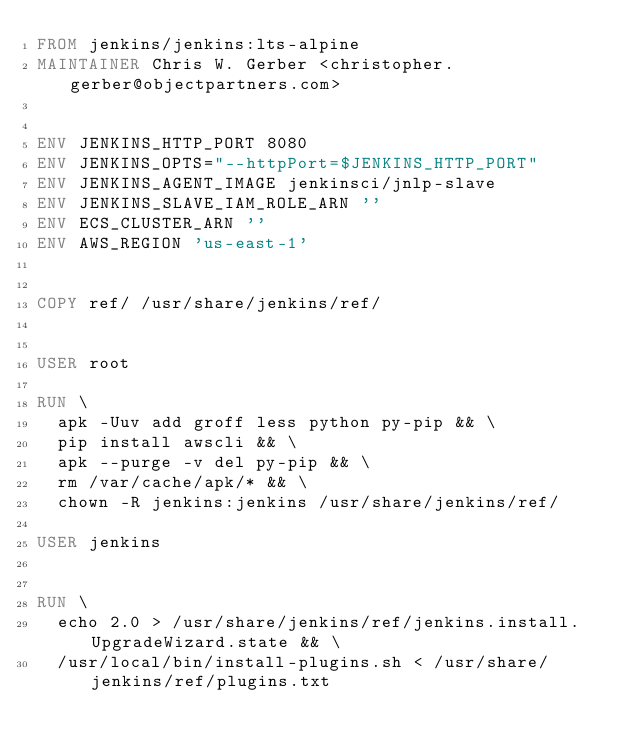<code> <loc_0><loc_0><loc_500><loc_500><_Dockerfile_>FROM jenkins/jenkins:lts-alpine
MAINTAINER Chris W. Gerber <christopher.gerber@objectpartners.com>


ENV JENKINS_HTTP_PORT 8080
ENV JENKINS_OPTS="--httpPort=$JENKINS_HTTP_PORT"
ENV JENKINS_AGENT_IMAGE jenkinsci/jnlp-slave
ENV JENKINS_SLAVE_IAM_ROLE_ARN ''
ENV ECS_CLUSTER_ARN ''
ENV AWS_REGION 'us-east-1'


COPY ref/ /usr/share/jenkins/ref/


USER root

RUN \
  apk -Uuv add groff less python py-pip && \
  pip install awscli && \
  apk --purge -v del py-pip && \
  rm /var/cache/apk/* && \
  chown -R jenkins:jenkins /usr/share/jenkins/ref/

USER jenkins


RUN \
  echo 2.0 > /usr/share/jenkins/ref/jenkins.install.UpgradeWizard.state && \
  /usr/local/bin/install-plugins.sh < /usr/share/jenkins/ref/plugins.txt
</code> 